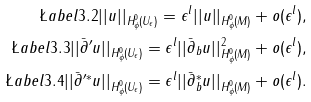Convert formula to latex. <formula><loc_0><loc_0><loc_500><loc_500>\L a b e l { 3 . 2 } | | u | | _ { H ^ { 0 } _ { \phi } ( U _ { \epsilon } ) } = \epsilon ^ { l } | | u | | _ { H ^ { 0 } _ { \phi } ( M ) } + o ( \epsilon ^ { l } ) , \\ \L a b e l { 3 . 3 } | | \bar { \partial } ^ { \prime } u | | _ { H ^ { 0 } _ { \phi } ( U _ { \epsilon } ) } = \epsilon ^ { l } | | \bar { \partial } _ { b } u | | ^ { 2 } _ { H ^ { 0 } _ { \phi } ( M ) } + o ( \epsilon ^ { l } ) , \\ \L a b e l { 3 . 4 } | | \bar { \partial } ^ { \prime * } u | | _ { H ^ { 0 } _ { \phi } ( U _ { \epsilon } ) } = \epsilon ^ { l } | | \bar { \partial } ^ { * } _ { b } u | | _ { H ^ { 0 } _ { \phi } ( M ) } + o ( \epsilon ^ { l } ) .</formula> 